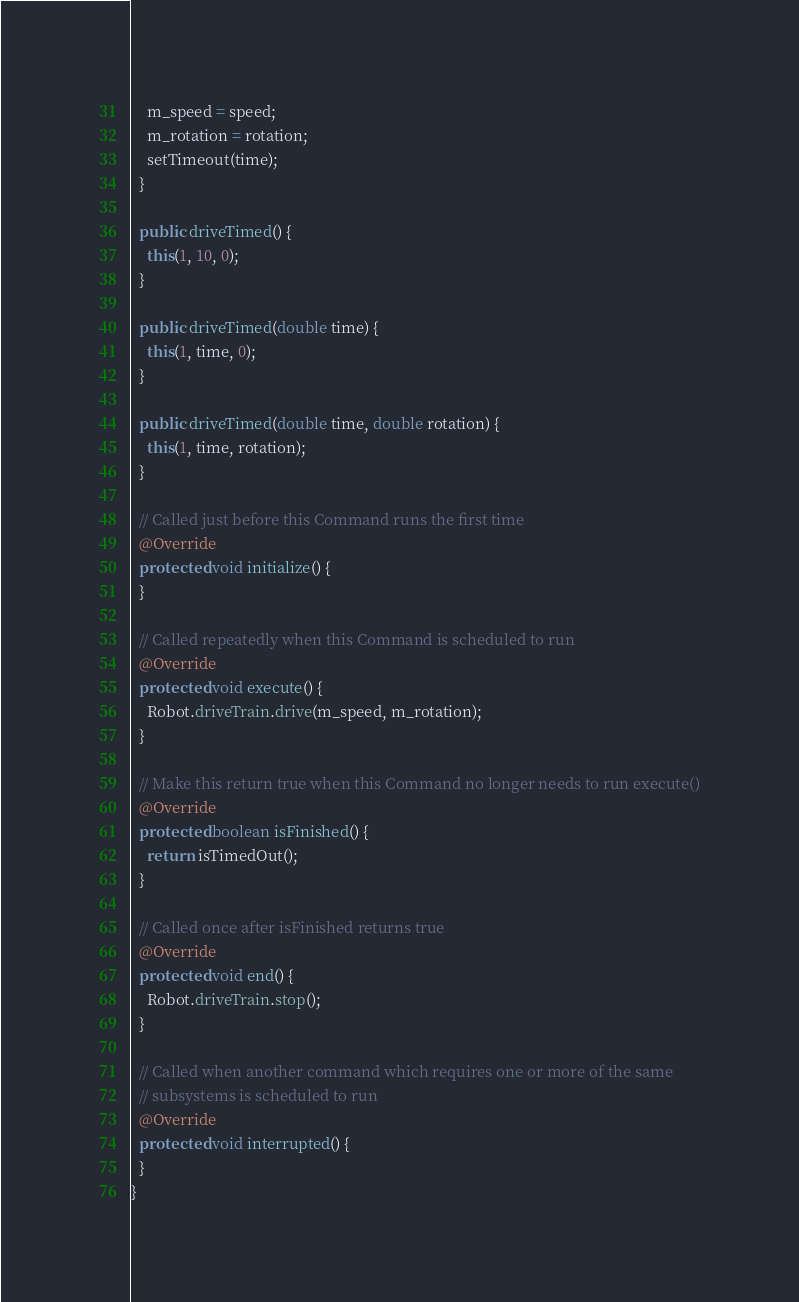Convert code to text. <code><loc_0><loc_0><loc_500><loc_500><_Java_>    m_speed = speed;
    m_rotation = rotation;
    setTimeout(time);
  }

  public driveTimed() {
    this(1, 10, 0);
  }

  public driveTimed(double time) {
    this(1, time, 0);
  }

  public driveTimed(double time, double rotation) {
    this(1, time, rotation);
  }

  // Called just before this Command runs the first time
  @Override
  protected void initialize() {
  }

  // Called repeatedly when this Command is scheduled to run
  @Override
  protected void execute() {
    Robot.driveTrain.drive(m_speed, m_rotation);
  }

  // Make this return true when this Command no longer needs to run execute()
  @Override
  protected boolean isFinished() {
    return isTimedOut();
  }

  // Called once after isFinished returns true
  @Override
  protected void end() {
    Robot.driveTrain.stop();
  }

  // Called when another command which requires one or more of the same
  // subsystems is scheduled to run
  @Override
  protected void interrupted() {
  }
}
</code> 